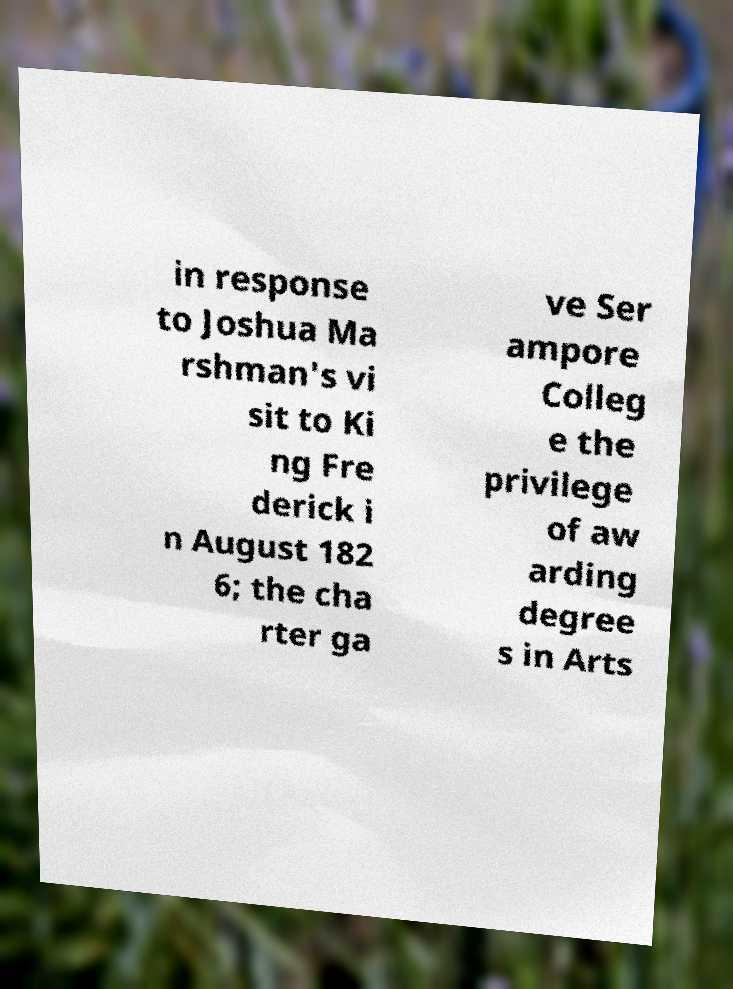Please identify and transcribe the text found in this image. in response to Joshua Ma rshman's vi sit to Ki ng Fre derick i n August 182 6; the cha rter ga ve Ser ampore Colleg e the privilege of aw arding degree s in Arts 